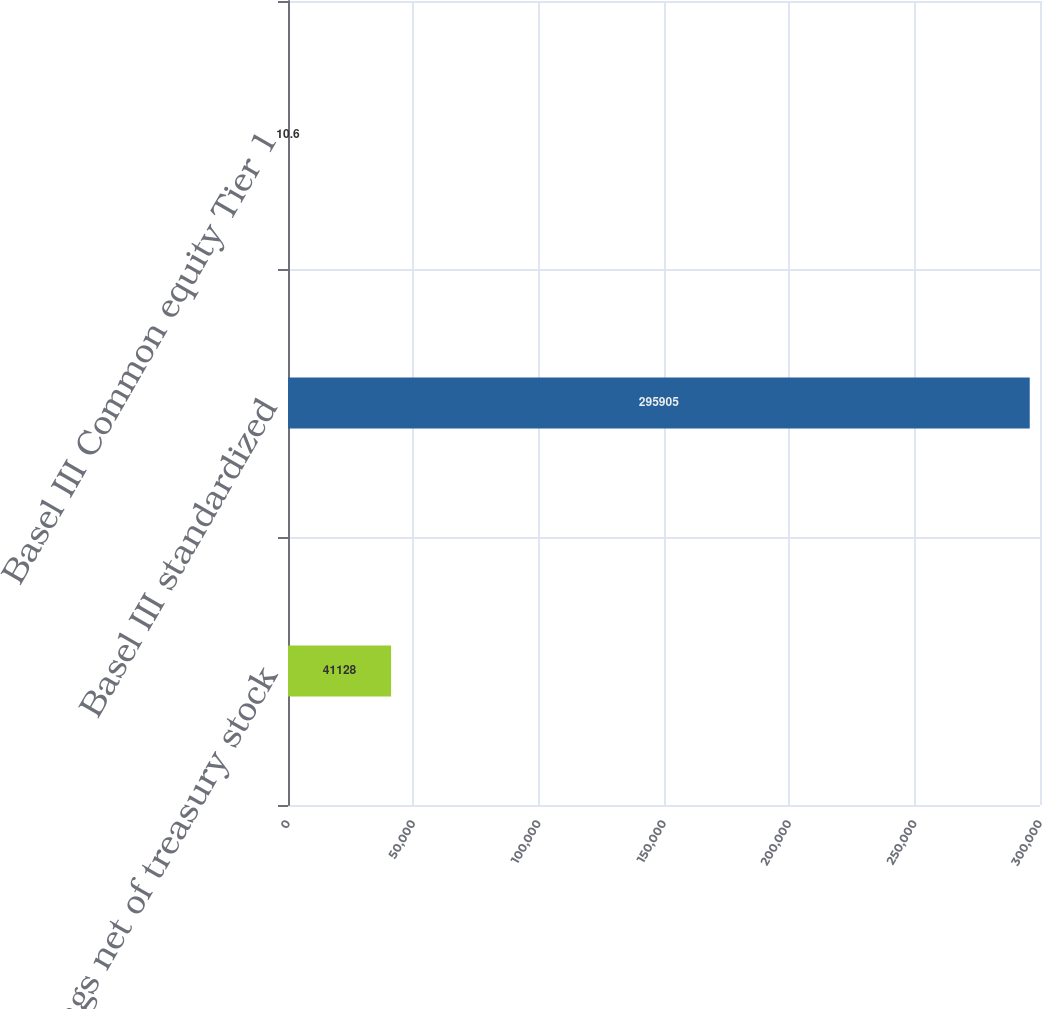Convert chart. <chart><loc_0><loc_0><loc_500><loc_500><bar_chart><fcel>earnings net of treasury stock<fcel>Basel III standardized<fcel>Basel III Common equity Tier 1<nl><fcel>41128<fcel>295905<fcel>10.6<nl></chart> 